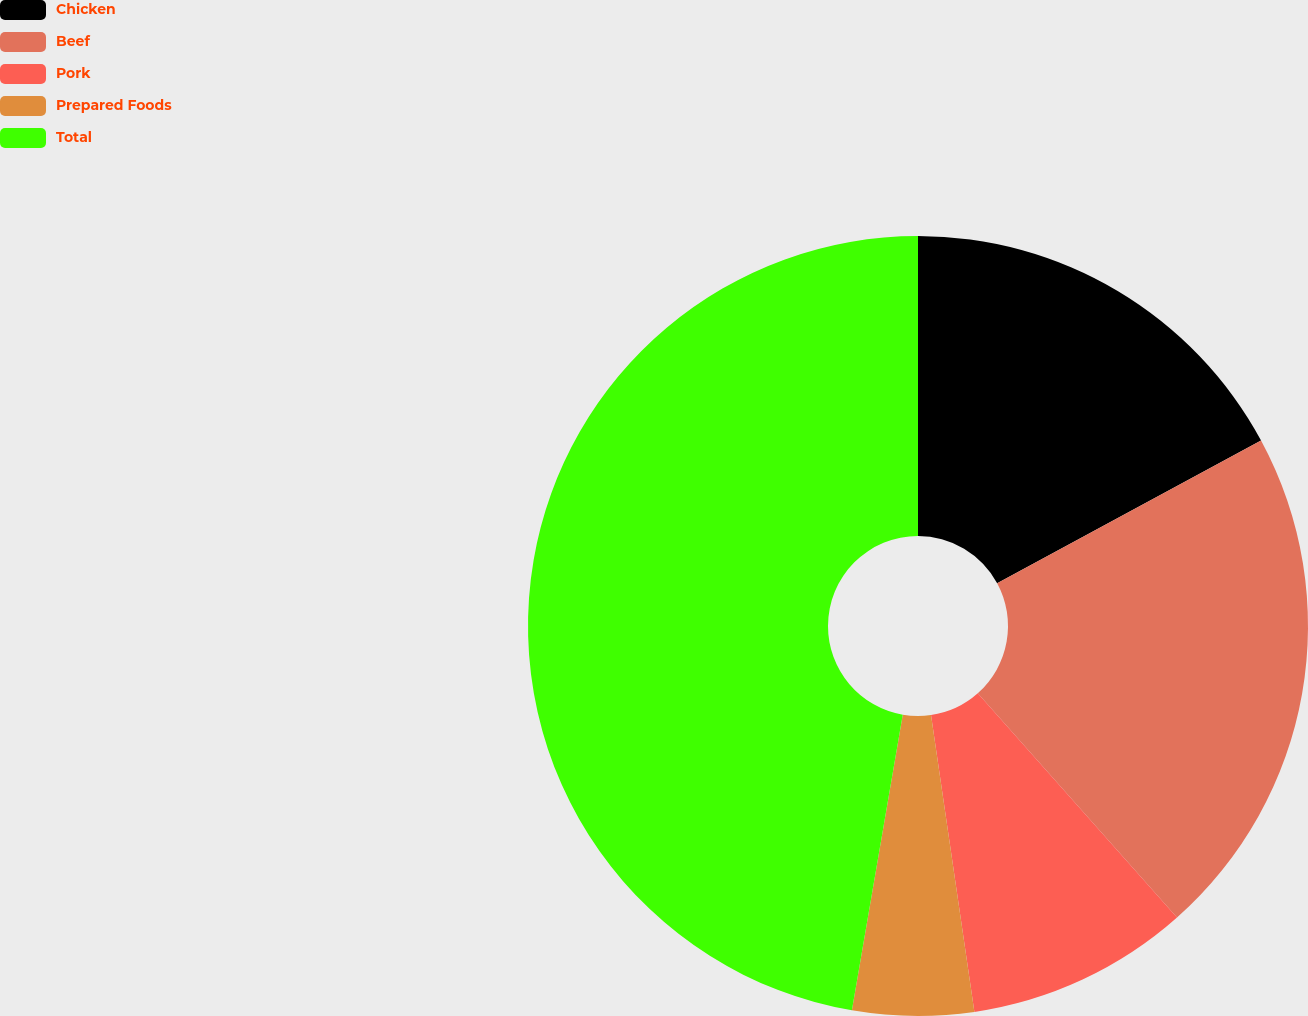<chart> <loc_0><loc_0><loc_500><loc_500><pie_chart><fcel>Chicken<fcel>Beef<fcel>Pork<fcel>Prepared Foods<fcel>Total<nl><fcel>17.11%<fcel>21.33%<fcel>9.25%<fcel>5.02%<fcel>47.29%<nl></chart> 